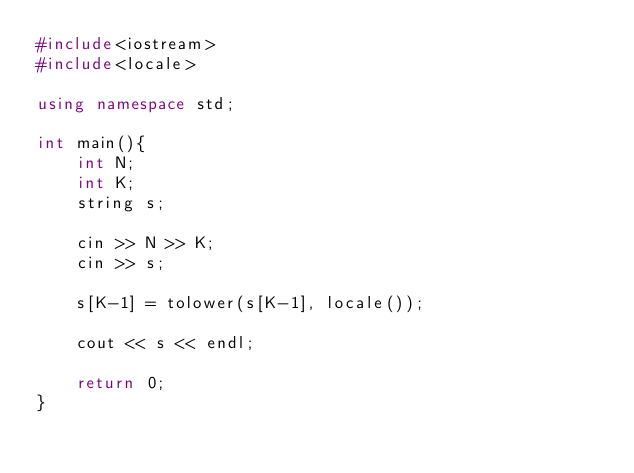Convert code to text. <code><loc_0><loc_0><loc_500><loc_500><_C++_>#include<iostream>
#include<locale>

using namespace std;

int main(){
    int N;
    int K;
    string s;

    cin >> N >> K;
    cin >> s;

    s[K-1] = tolower(s[K-1], locale());

    cout << s << endl;

    return 0;
}</code> 